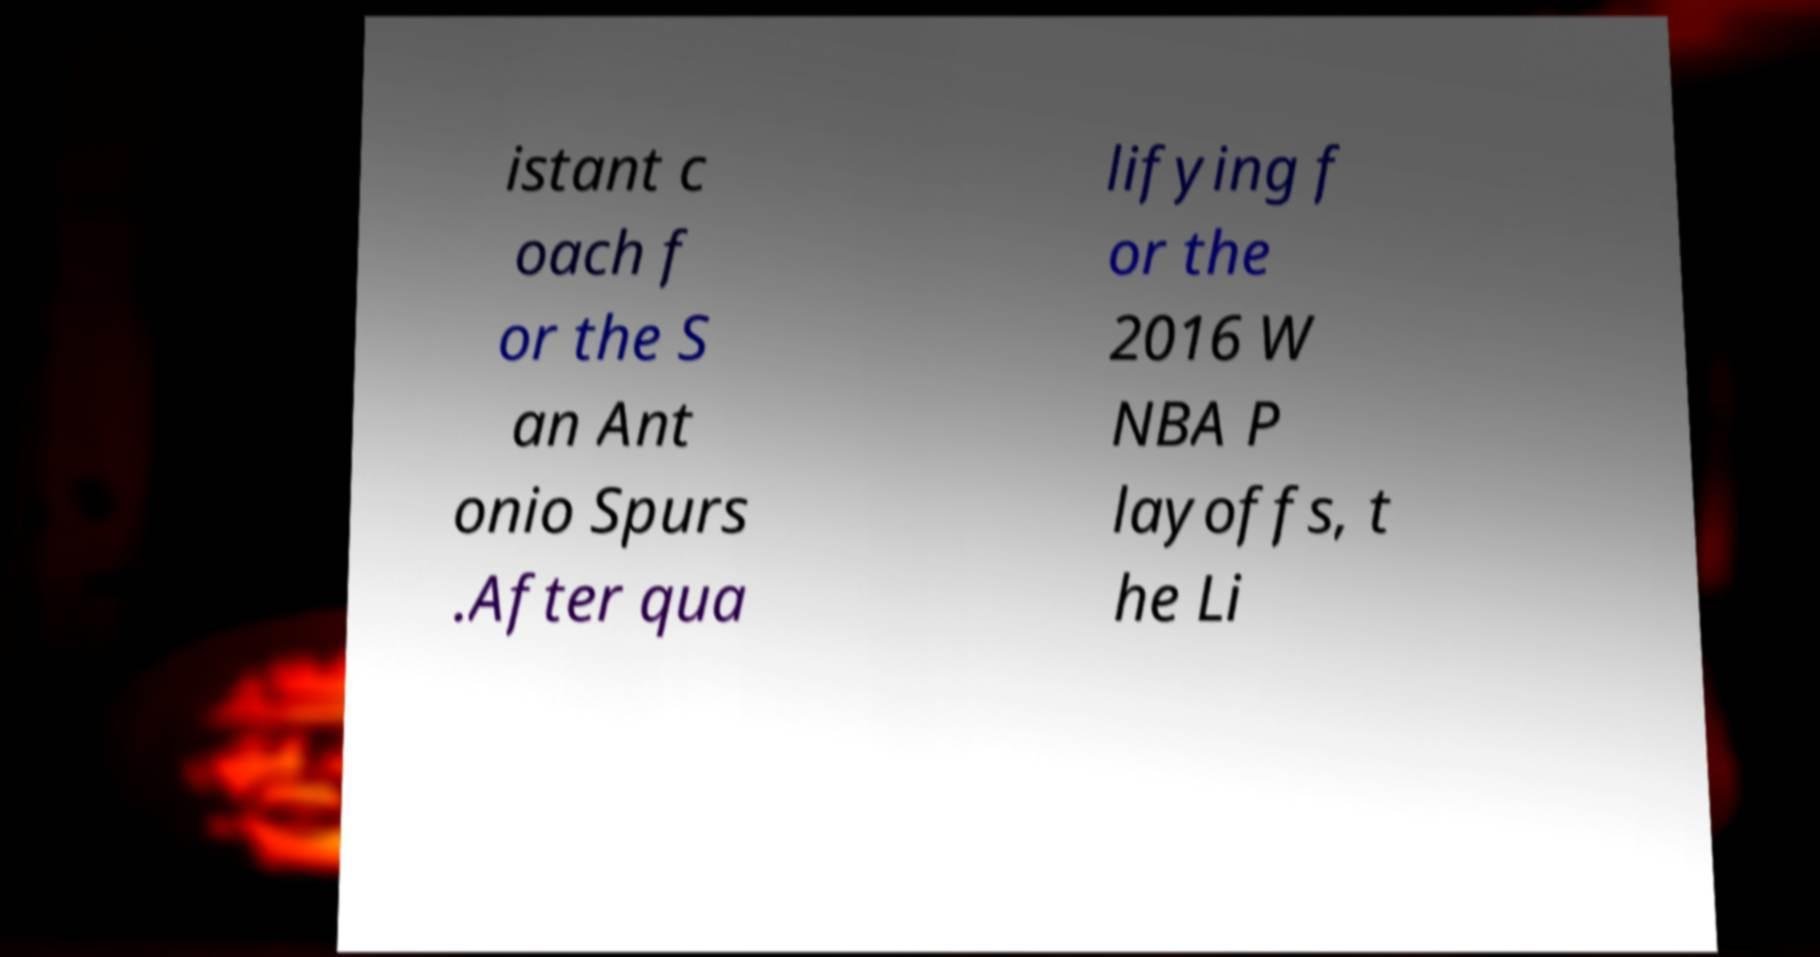I need the written content from this picture converted into text. Can you do that? istant c oach f or the S an Ant onio Spurs .After qua lifying f or the 2016 W NBA P layoffs, t he Li 